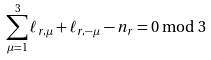Convert formula to latex. <formula><loc_0><loc_0><loc_500><loc_500>\sum _ { \mu = 1 } ^ { 3 } \ell _ { r , \mu } + \ell _ { r , - \mu } - n _ { r } = 0 \bmod 3</formula> 